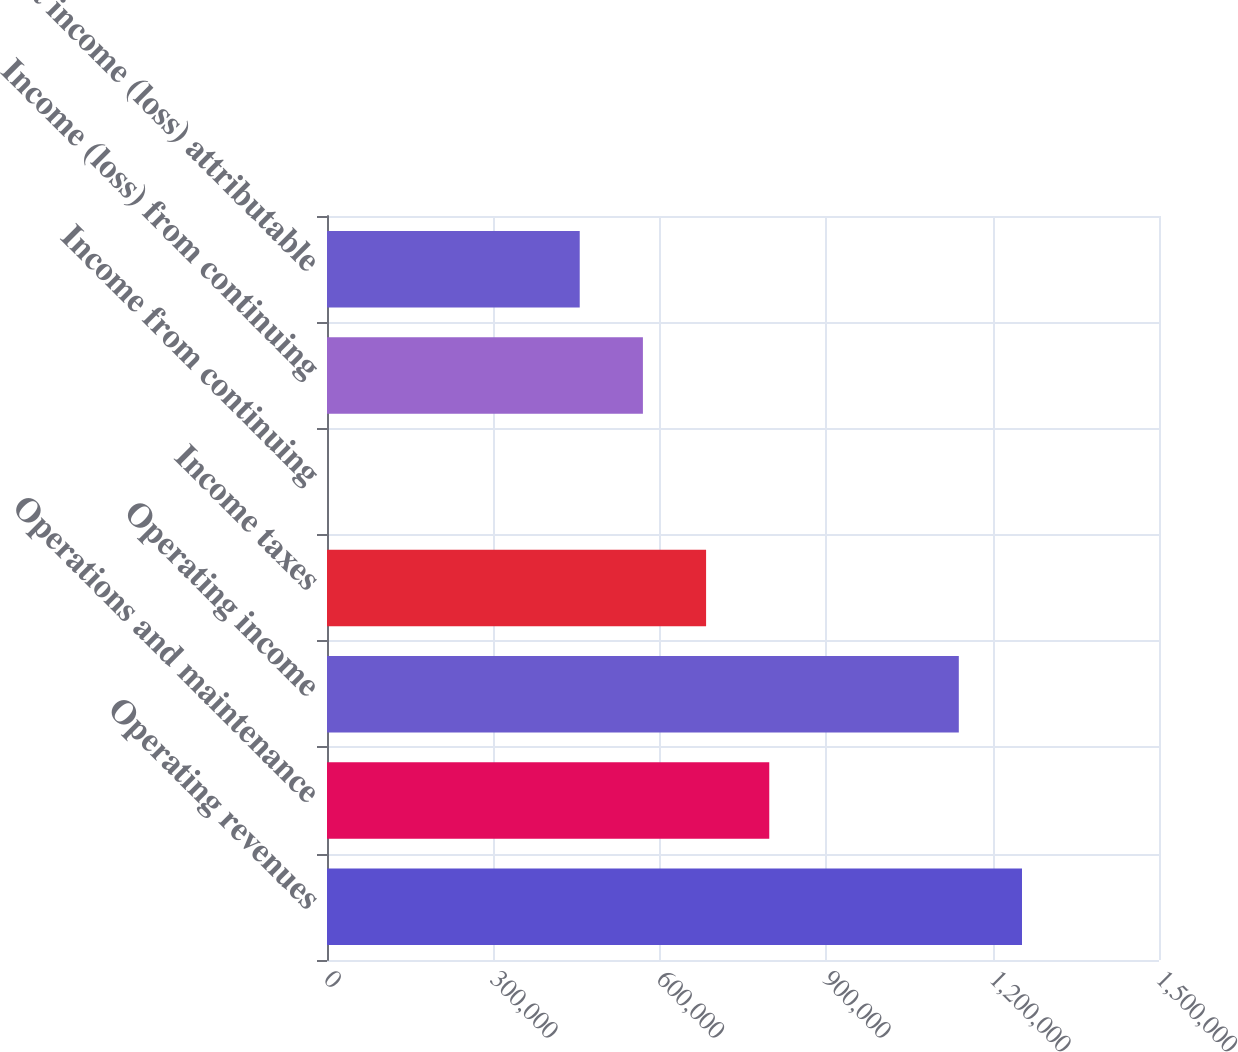Convert chart to OTSL. <chart><loc_0><loc_0><loc_500><loc_500><bar_chart><fcel>Operating revenues<fcel>Operations and maintenance<fcel>Operating income<fcel>Income taxes<fcel>Income from continuing<fcel>Income (loss) from continuing<fcel>Net income (loss) attributable<nl><fcel>1.25299e+06<fcel>797360<fcel>1.13908e+06<fcel>683452<fcel>2.08<fcel>569544<fcel>455635<nl></chart> 